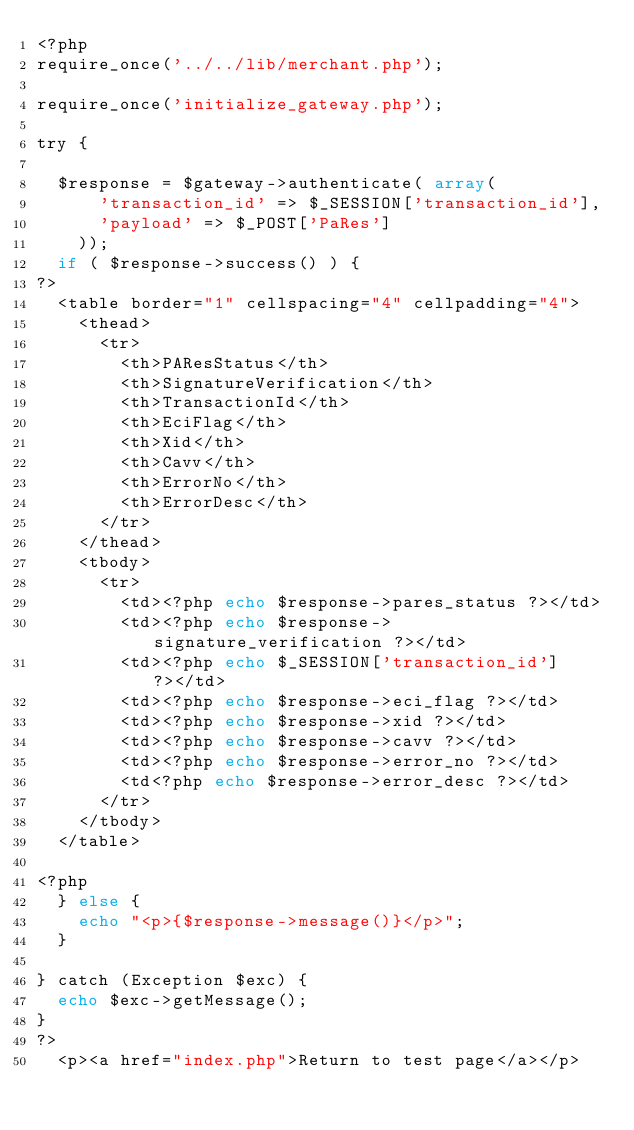<code> <loc_0><loc_0><loc_500><loc_500><_PHP_><?php 
require_once('../../lib/merchant.php');

require_once('initialize_gateway.php');

try {

  $response = $gateway->authenticate( array(
      'transaction_id' => $_SESSION['transaction_id'],
      'payload' => $_POST['PaRes']
    ));
  if ( $response->success() ) {
?>
  <table border="1" cellspacing="4" cellpadding="4">
    <thead>
      <tr>
        <th>PAResStatus</th>
        <th>SignatureVerification</th>
        <th>TransactionId</th>
        <th>EciFlag</th>
        <th>Xid</th>
        <th>Cavv</th>
        <th>ErrorNo</th>
        <th>ErrorDesc</th>
      </tr>
    </thead>
    <tbody>
      <tr>
        <td><?php echo $response->pares_status ?></td>
        <td><?php echo $response->signature_verification ?></td>
        <td><?php echo $_SESSION['transaction_id'] ?></td>
        <td><?php echo $response->eci_flag ?></td> 
        <td><?php echo $response->xid ?></td>
        <td><?php echo $response->cavv ?></td>
        <td><?php echo $response->error_no ?></td>
        <td<?php echo $response->error_desc ?></td>
      </tr>
    </tbody>
  </table>

<?php
  } else {
    echo "<p>{$response->message()}</p>";
  }

} catch (Exception $exc) {
  echo $exc->getMessage();
}
?>
  <p><a href="index.php">Return to test page</a></p>
</code> 